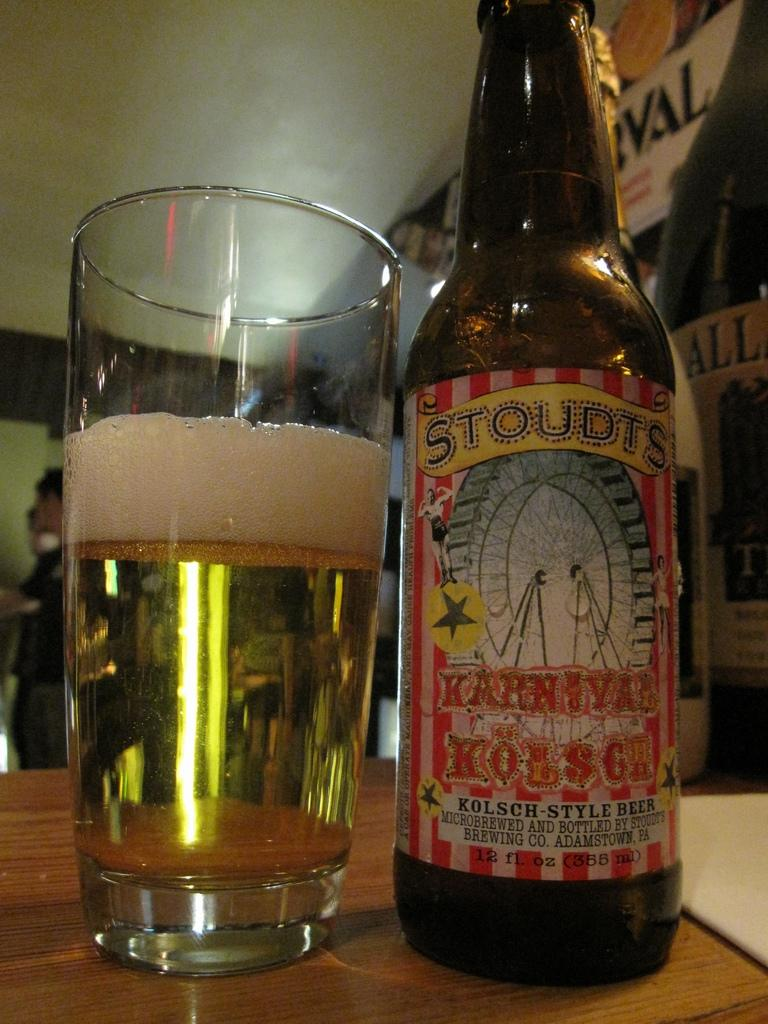<image>
Summarize the visual content of the image. A Glass of bear with a bottle on the side shows Stoudts Karnival brand 